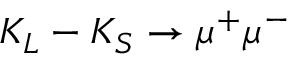<formula> <loc_0><loc_0><loc_500><loc_500>K _ { L } - K _ { S } \rightarrow \mu ^ { + } \mu ^ { - }</formula> 